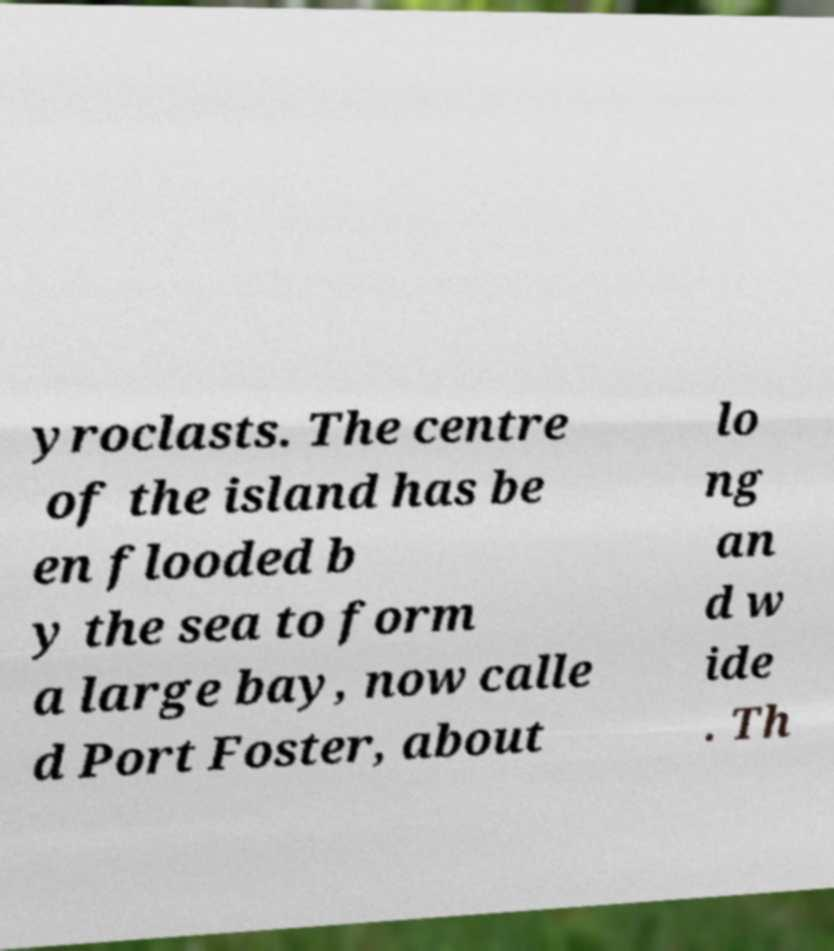Can you accurately transcribe the text from the provided image for me? yroclasts. The centre of the island has be en flooded b y the sea to form a large bay, now calle d Port Foster, about lo ng an d w ide . Th 